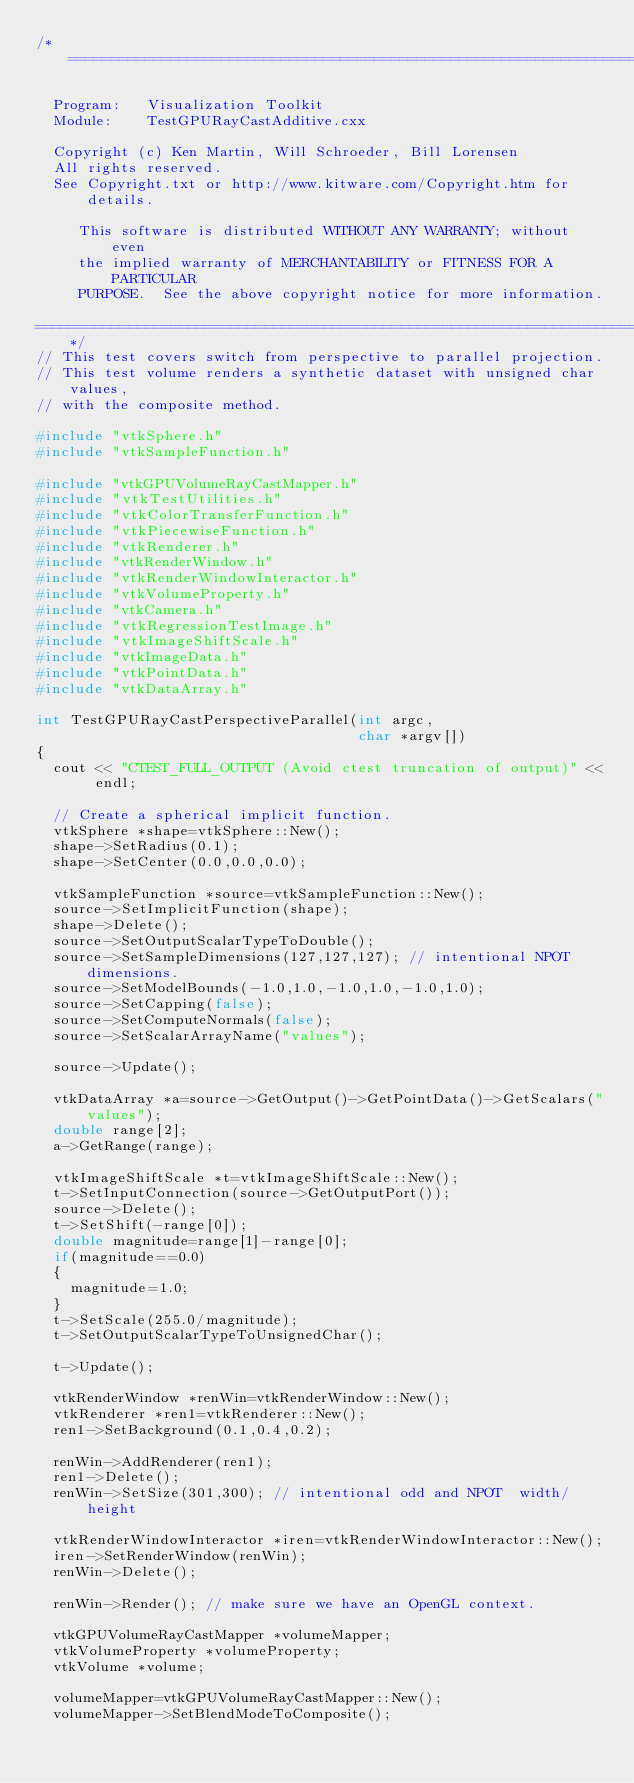Convert code to text. <code><loc_0><loc_0><loc_500><loc_500><_C++_>/*=========================================================================

  Program:   Visualization Toolkit
  Module:    TestGPURayCastAdditive.cxx

  Copyright (c) Ken Martin, Will Schroeder, Bill Lorensen
  All rights reserved.
  See Copyright.txt or http://www.kitware.com/Copyright.htm for details.

     This software is distributed WITHOUT ANY WARRANTY; without even
     the implied warranty of MERCHANTABILITY or FITNESS FOR A PARTICULAR
     PURPOSE.  See the above copyright notice for more information.

=========================================================================*/
// This test covers switch from perspective to parallel projection.
// This test volume renders a synthetic dataset with unsigned char values,
// with the composite method.

#include "vtkSphere.h"
#include "vtkSampleFunction.h"

#include "vtkGPUVolumeRayCastMapper.h"
#include "vtkTestUtilities.h"
#include "vtkColorTransferFunction.h"
#include "vtkPiecewiseFunction.h"
#include "vtkRenderer.h"
#include "vtkRenderWindow.h"
#include "vtkRenderWindowInteractor.h"
#include "vtkVolumeProperty.h"
#include "vtkCamera.h"
#include "vtkRegressionTestImage.h"
#include "vtkImageShiftScale.h"
#include "vtkImageData.h"
#include "vtkPointData.h"
#include "vtkDataArray.h"

int TestGPURayCastPerspectiveParallel(int argc,
                                      char *argv[])
{
  cout << "CTEST_FULL_OUTPUT (Avoid ctest truncation of output)" << endl;

  // Create a spherical implicit function.
  vtkSphere *shape=vtkSphere::New();
  shape->SetRadius(0.1);
  shape->SetCenter(0.0,0.0,0.0);

  vtkSampleFunction *source=vtkSampleFunction::New();
  source->SetImplicitFunction(shape);
  shape->Delete();
  source->SetOutputScalarTypeToDouble();
  source->SetSampleDimensions(127,127,127); // intentional NPOT dimensions.
  source->SetModelBounds(-1.0,1.0,-1.0,1.0,-1.0,1.0);
  source->SetCapping(false);
  source->SetComputeNormals(false);
  source->SetScalarArrayName("values");

  source->Update();

  vtkDataArray *a=source->GetOutput()->GetPointData()->GetScalars("values");
  double range[2];
  a->GetRange(range);

  vtkImageShiftScale *t=vtkImageShiftScale::New();
  t->SetInputConnection(source->GetOutputPort());
  source->Delete();
  t->SetShift(-range[0]);
  double magnitude=range[1]-range[0];
  if(magnitude==0.0)
  {
    magnitude=1.0;
  }
  t->SetScale(255.0/magnitude);
  t->SetOutputScalarTypeToUnsignedChar();

  t->Update();

  vtkRenderWindow *renWin=vtkRenderWindow::New();
  vtkRenderer *ren1=vtkRenderer::New();
  ren1->SetBackground(0.1,0.4,0.2);

  renWin->AddRenderer(ren1);
  ren1->Delete();
  renWin->SetSize(301,300); // intentional odd and NPOT  width/height

  vtkRenderWindowInteractor *iren=vtkRenderWindowInteractor::New();
  iren->SetRenderWindow(renWin);
  renWin->Delete();

  renWin->Render(); // make sure we have an OpenGL context.

  vtkGPUVolumeRayCastMapper *volumeMapper;
  vtkVolumeProperty *volumeProperty;
  vtkVolume *volume;

  volumeMapper=vtkGPUVolumeRayCastMapper::New();
  volumeMapper->SetBlendModeToComposite();</code> 